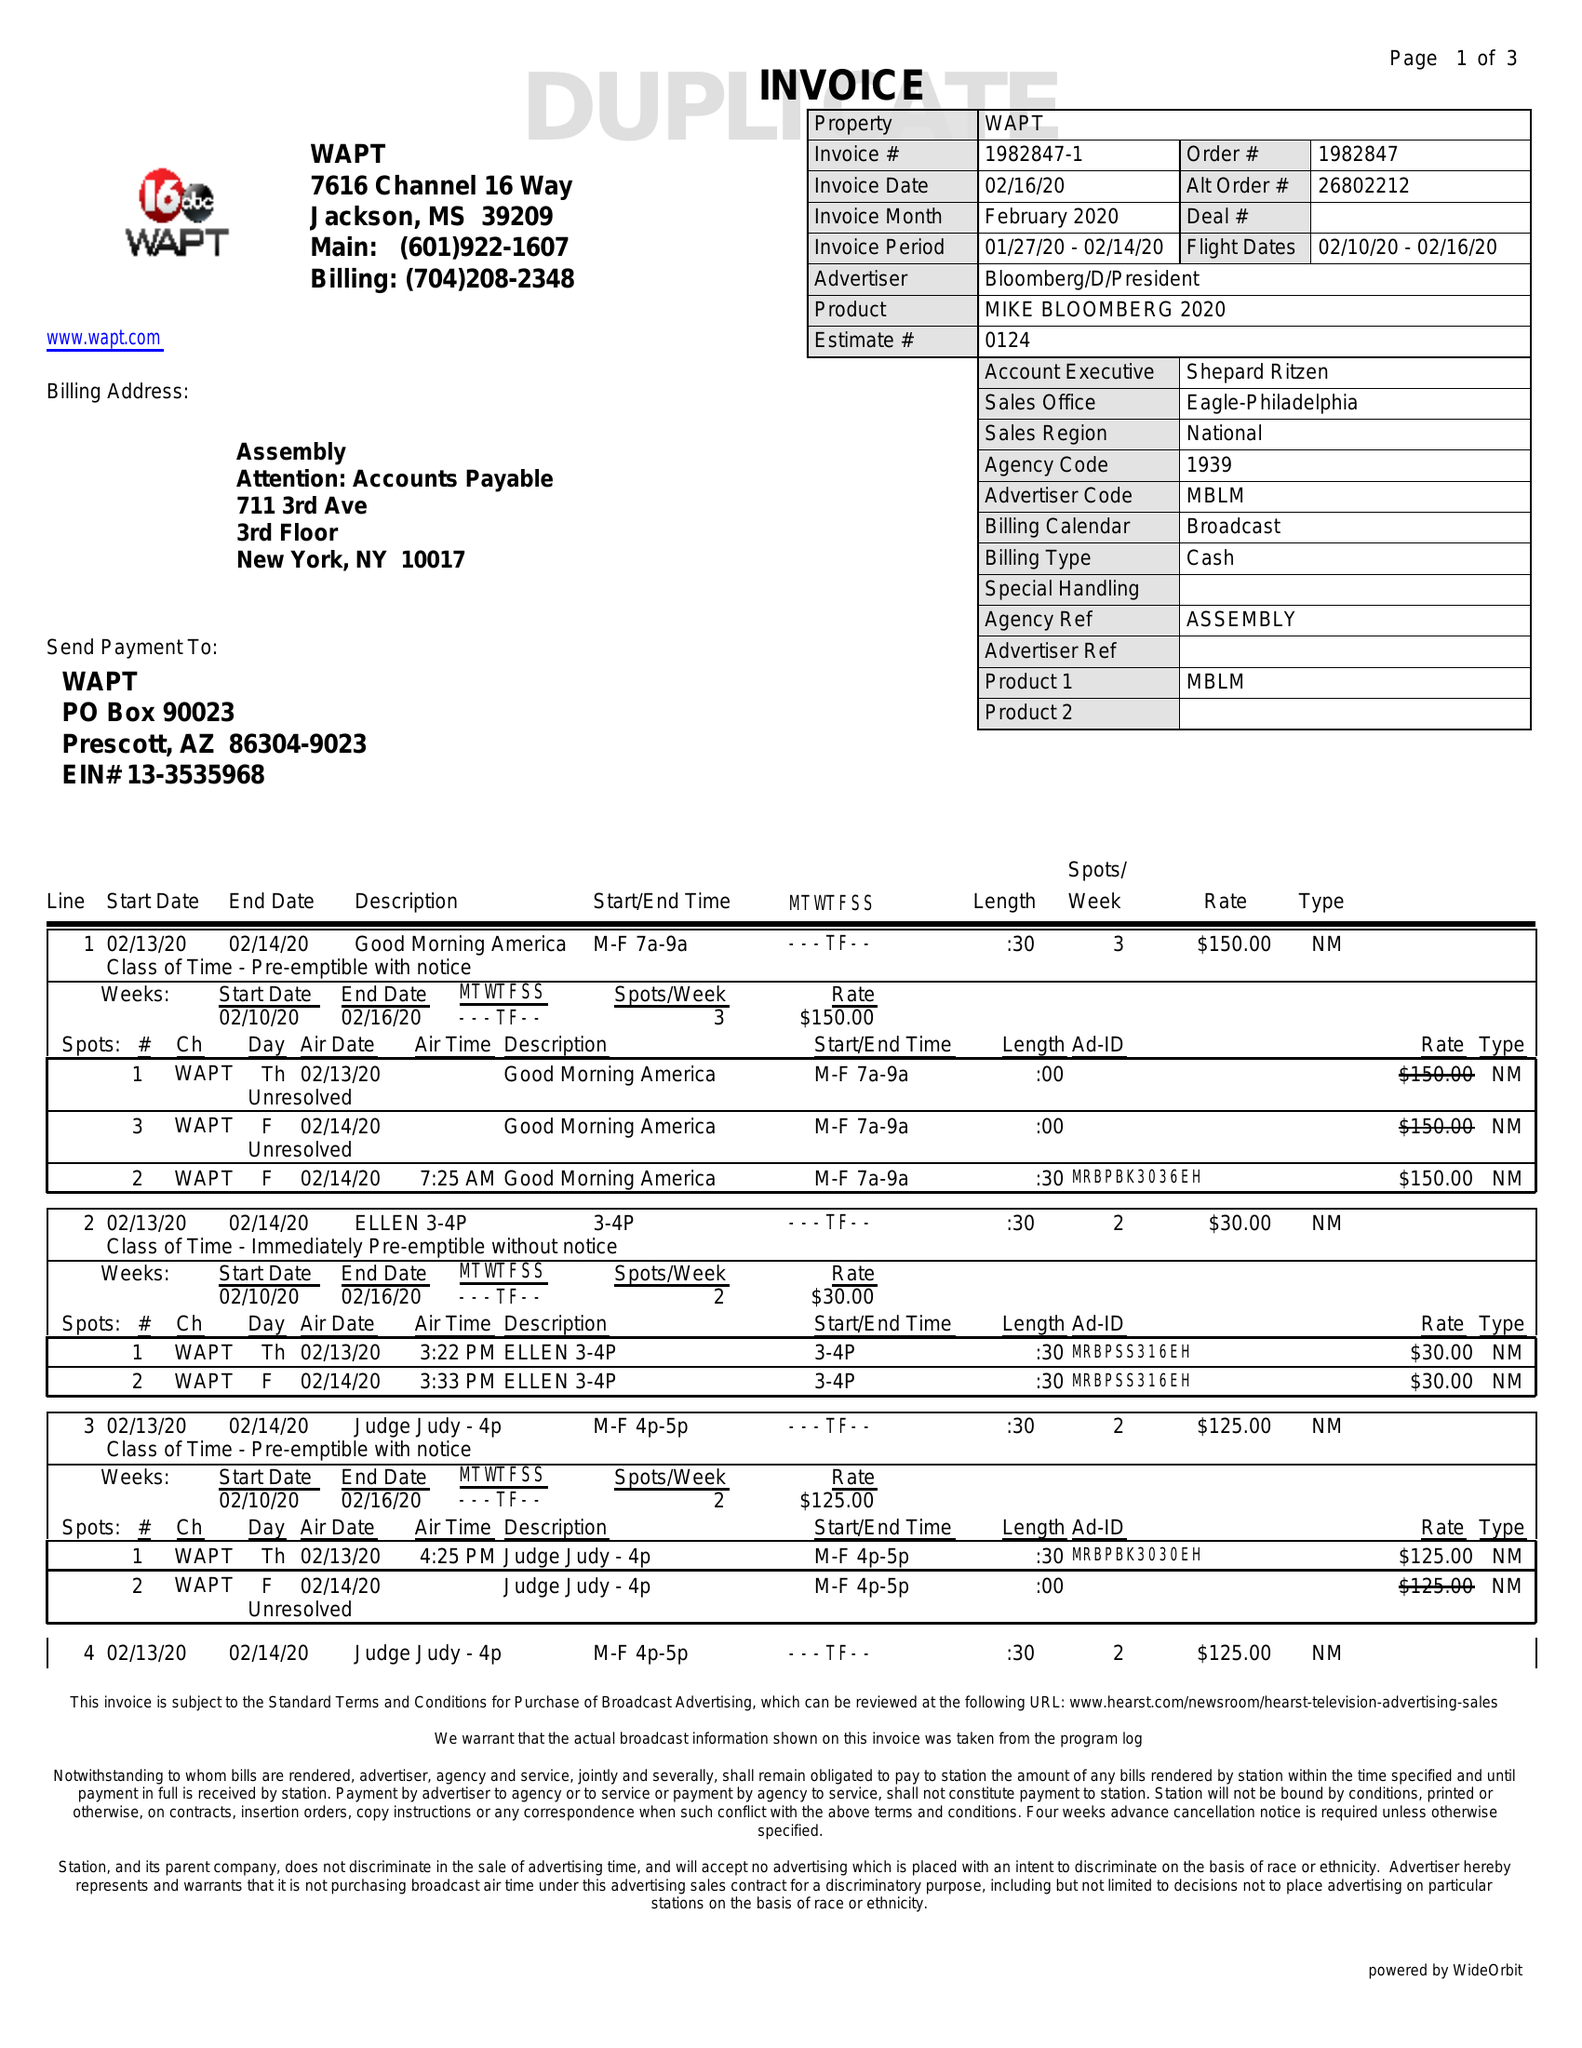What is the value for the gross_amount?
Answer the question using a single word or phrase. 1490.00 